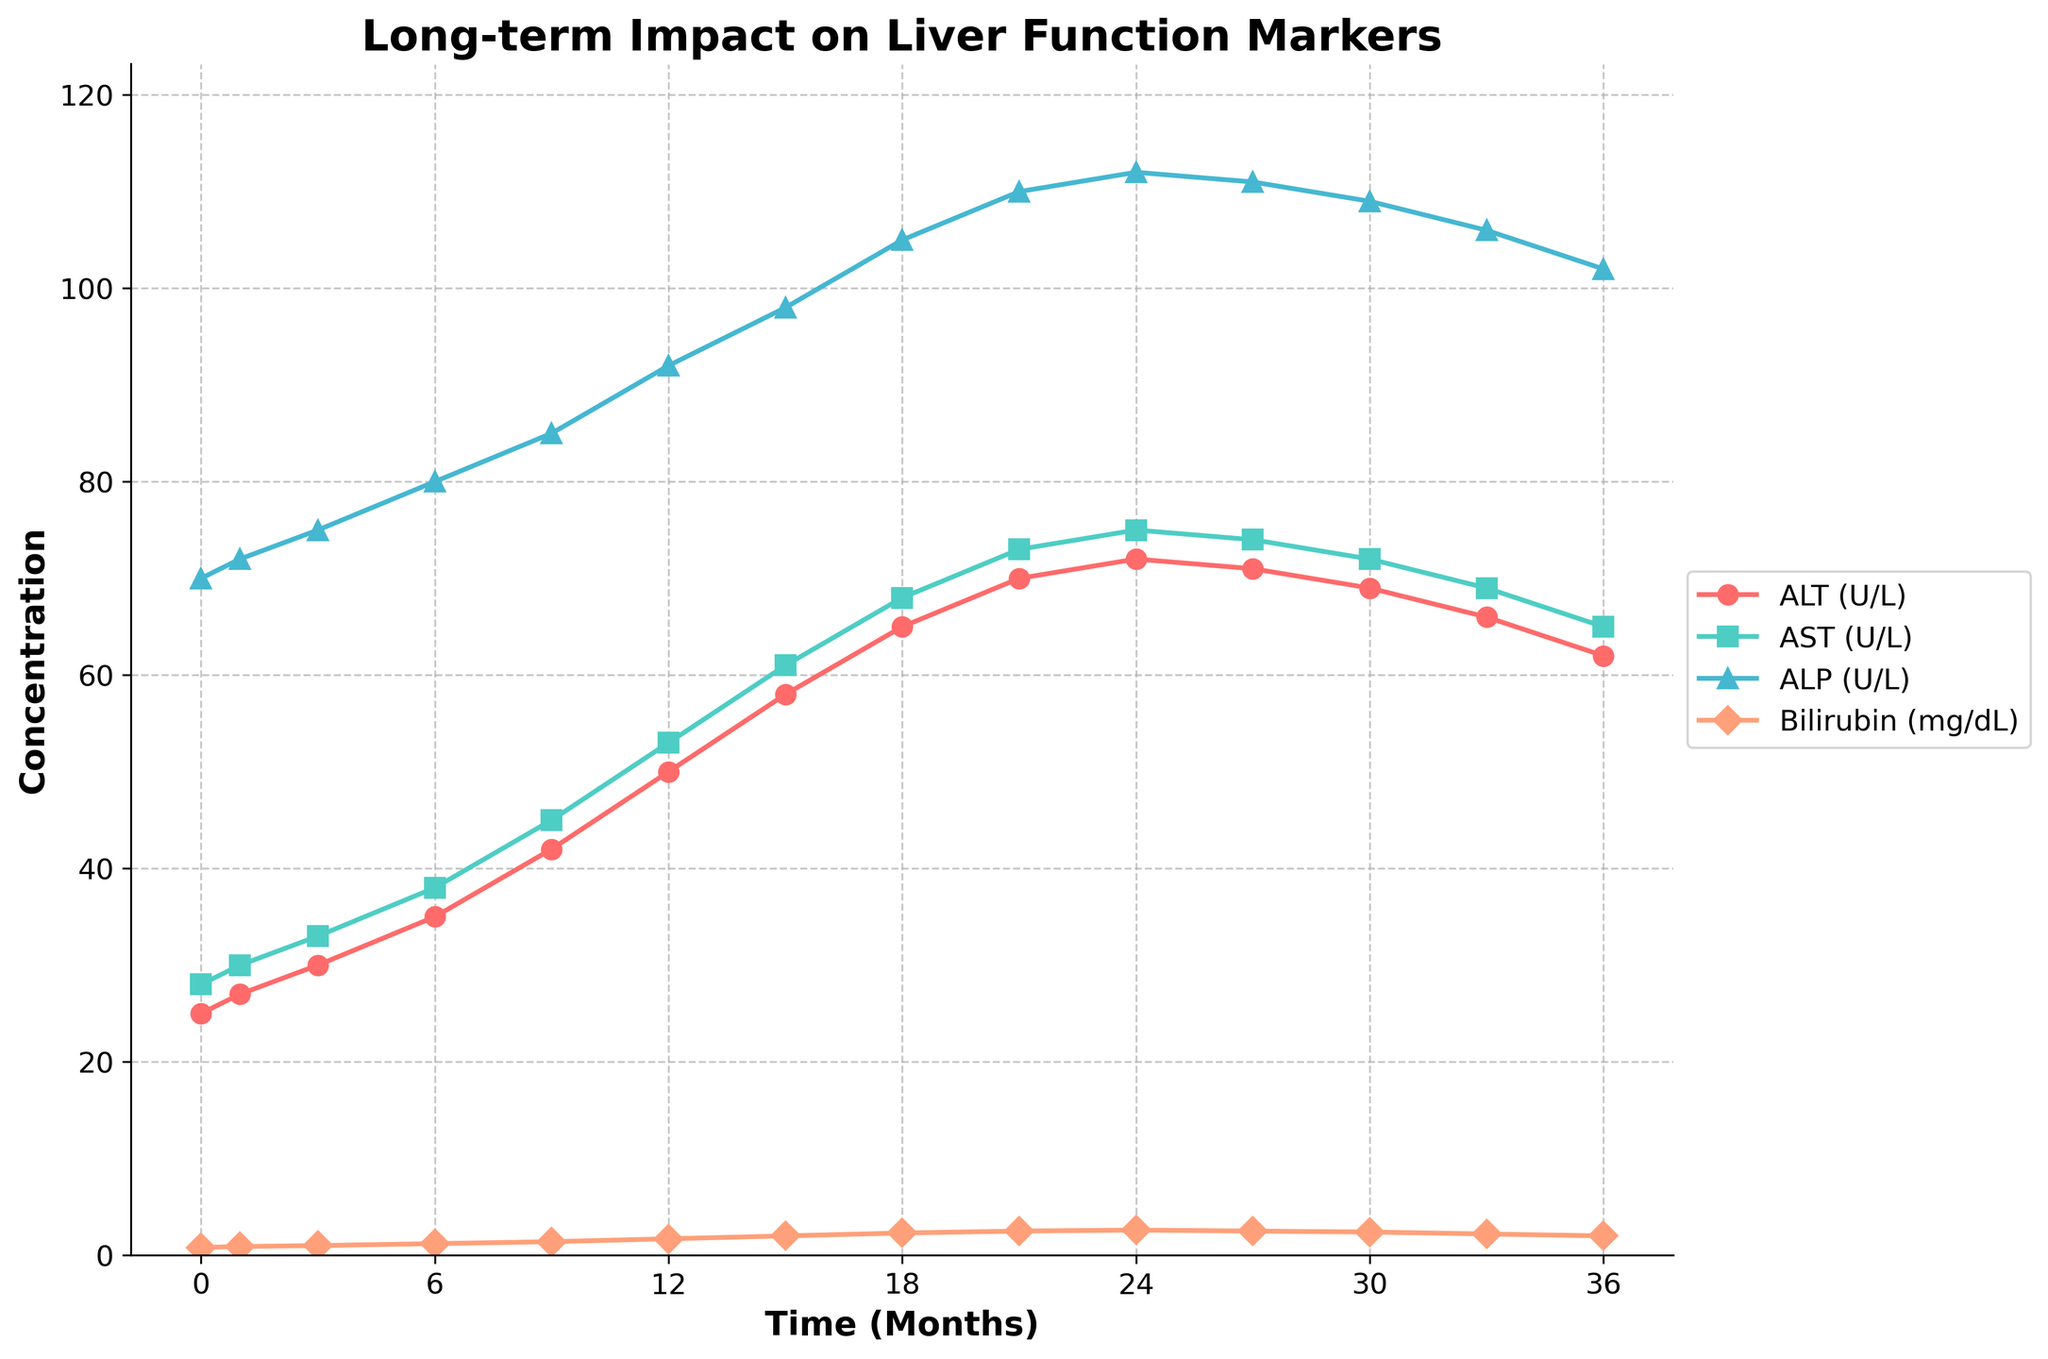Which liver function marker shows the highest value at the 24-month mark? We observe the graph at the 24-month time point and compare the values of ALT, AST, ALP, and Bilirubin.
Answer: ALT By how much did the AST level increase from 0 to 12 months? The AST value at 0 months is 28 and at 12 months is 53. Subtract the initial value from the final value: 53 - 28.
Answer: 25 Which marker had the steepest increase in the first 9 months? Compare the slopes (rate of change) of ALT, AST, ALP, and Bilirubin between 0 and 9 months. The steepness is reflected by the largest change in value.
Answer: ALT What is the average ALP concentration over the 36-month period? Sum up all the ALP values and divide by the number of time points (14). (70 + 72 + 75 + 80 + 85 + 92 + 98 + 105 + 110 + 112 + 111 + 109 + 106 + 102) / 14.
Answer: 93 Which marker's reading returned to its lowest level at the end of the 36-month period as compared to the highest point during the interval? Analyze the drop in values from the highest points for all markers between 0 and 36 months, focusing on the minimum values at 36 months.
Answer: ALT Between which months did Bilirubin's concentration show the greatest increase? Examine the increments in Bilirubin's concentration between each adjacent pair of time points and identify the largest increase.
Answer: 0-12 What is the difference in ALP levels between 18 months and 36 months? The ALP level at 18 months is 105 and at 36 months is 102. Subtract the final value from the initial value: 105 - 102.
Answer: 3 Compare the ALT and AST levels at the 21-month mark. Which one is higher? At the 21-month mark, compare the values of ALT and AST.
Answer: ALT Which marker maintained the most consistent level throughout the study period? Look for the marker with the smallest variation in values over time. This can be interpreted by looking at the smoothness or flatness of its line in the plot.
Answer: ALP 